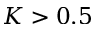Convert formula to latex. <formula><loc_0><loc_0><loc_500><loc_500>K > 0 . 5</formula> 